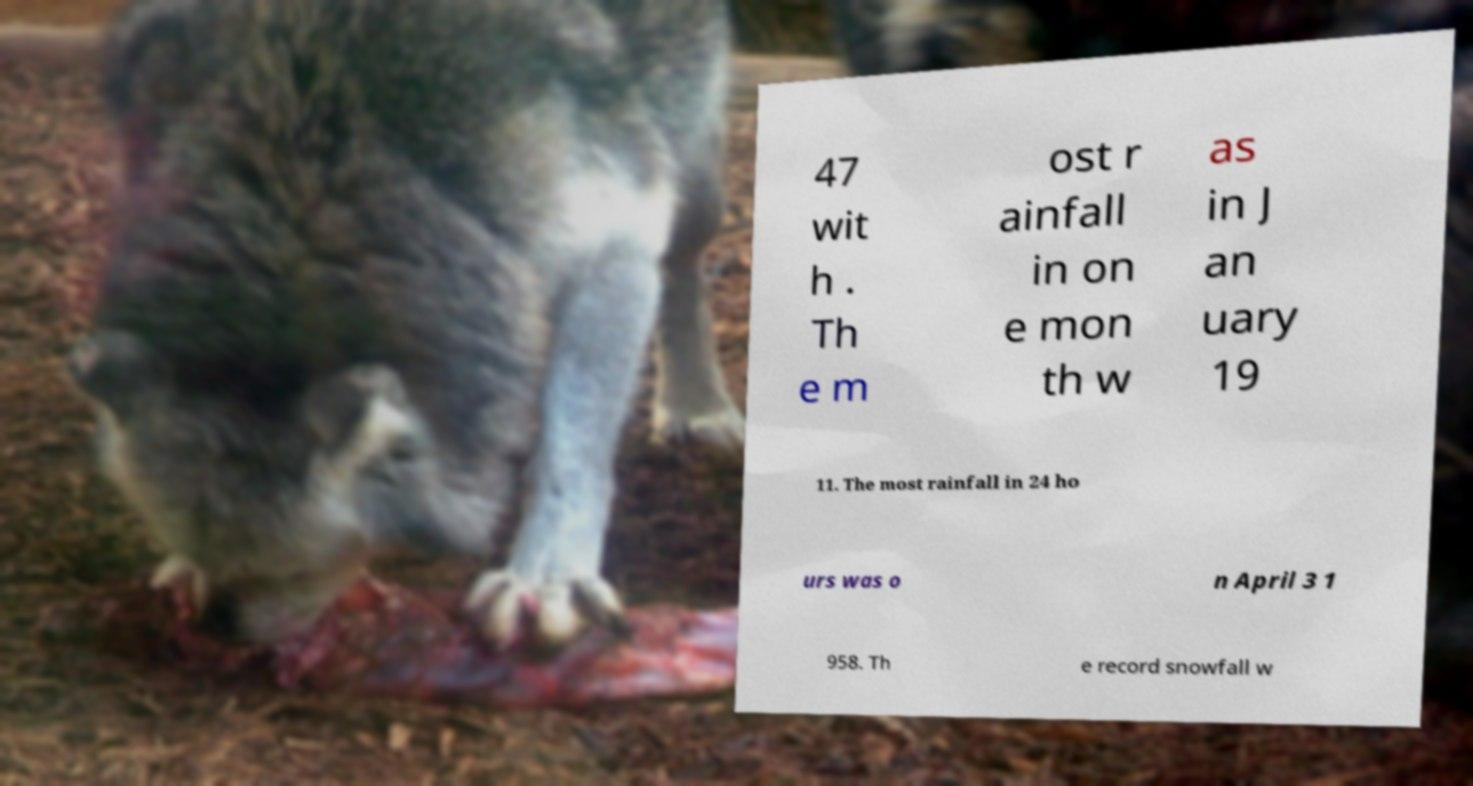Please identify and transcribe the text found in this image. 47 wit h . Th e m ost r ainfall in on e mon th w as in J an uary 19 11. The most rainfall in 24 ho urs was o n April 3 1 958. Th e record snowfall w 